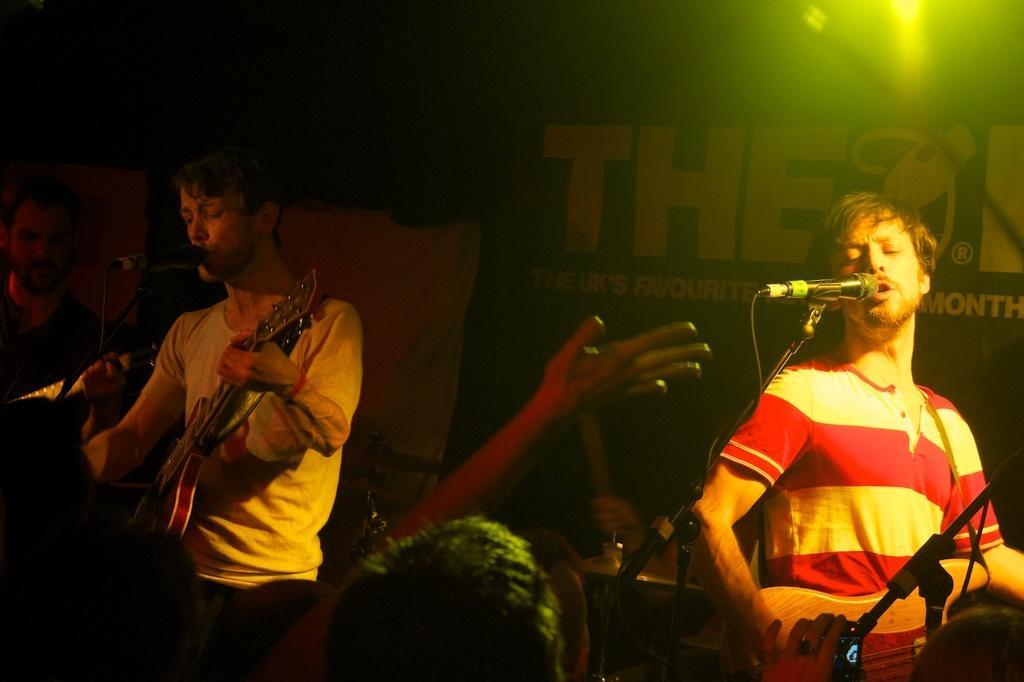In one or two sentences, can you explain what this image depicts? In this picture there is a man who is standing on the right is singing and playing the guitar and the person who is standing on the left his also single man playing the guitar the sum and beside him and in the background there is a banner. 